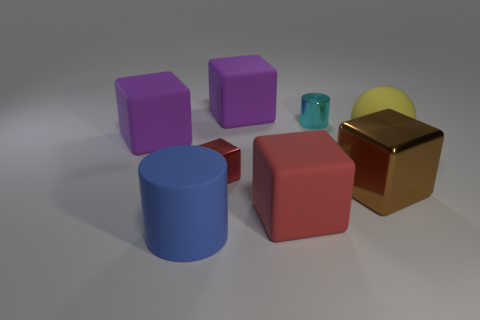Subtract all purple cubes. How many cubes are left? 3 Subtract all purple cubes. How many cubes are left? 3 Subtract 1 cubes. How many cubes are left? 4 Subtract all cylinders. How many objects are left? 6 Add 2 tiny cyan metallic cylinders. How many objects exist? 10 Subtract all red balls. How many red cubes are left? 2 Subtract all big cubes. Subtract all large brown cubes. How many objects are left? 3 Add 1 small red metal cubes. How many small red metal cubes are left? 2 Add 2 small red objects. How many small red objects exist? 3 Subtract 1 cyan cylinders. How many objects are left? 7 